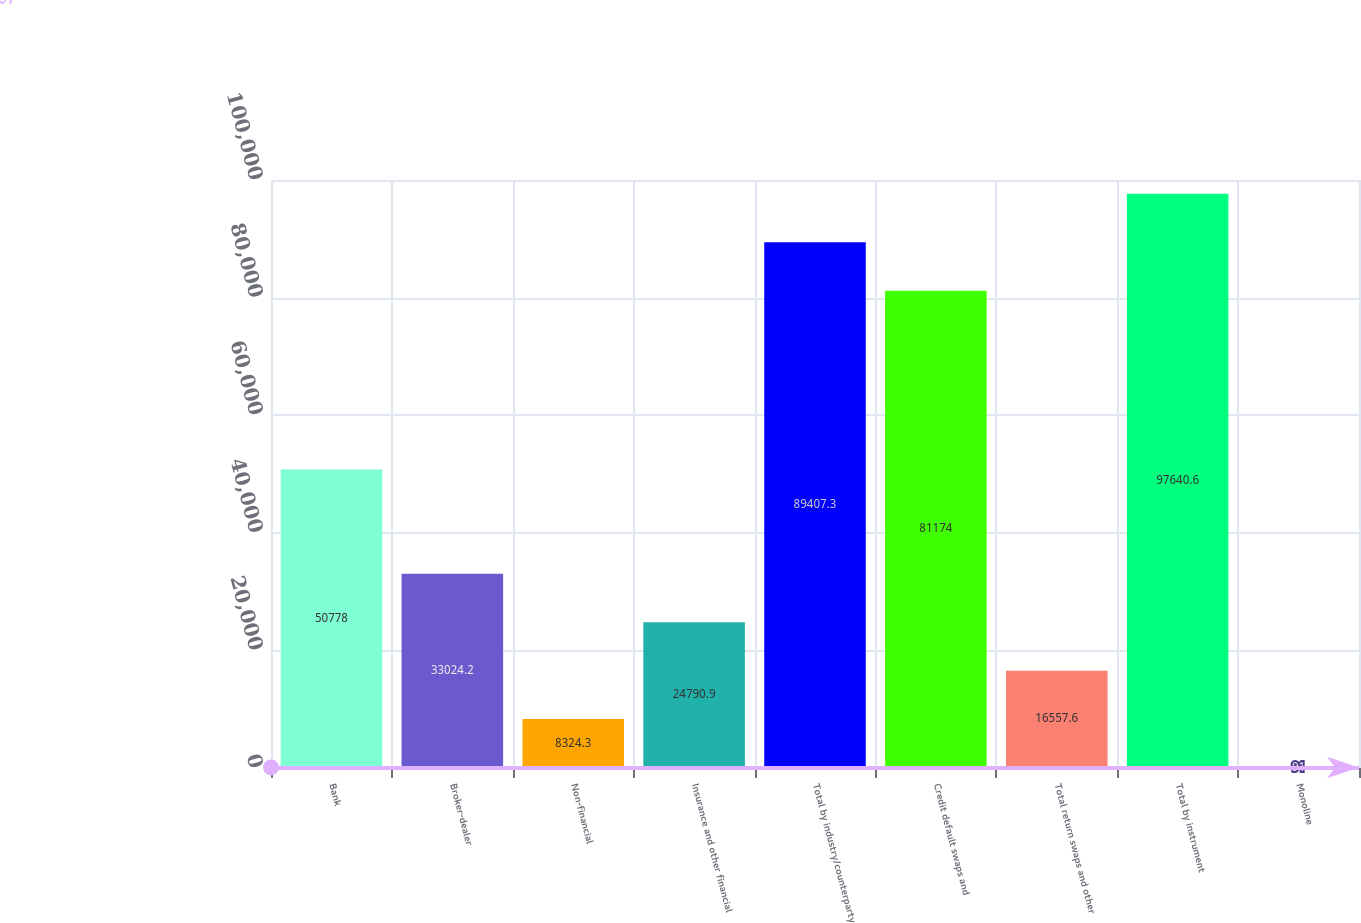Convert chart. <chart><loc_0><loc_0><loc_500><loc_500><bar_chart><fcel>Bank<fcel>Broker-dealer<fcel>Non-financial<fcel>Insurance and other financial<fcel>Total by industry/counterparty<fcel>Credit default swaps and<fcel>Total return swaps and other<fcel>Total by instrument<fcel>Monoline<nl><fcel>50778<fcel>33024.2<fcel>8324.3<fcel>24790.9<fcel>89407.3<fcel>81174<fcel>16557.6<fcel>97640.6<fcel>91<nl></chart> 